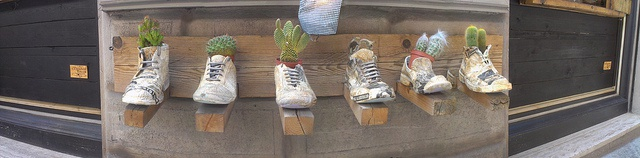Describe the objects in this image and their specific colors. I can see vase in gray, darkgray, and lightgray tones, vase in gray, darkgray, lightgray, brown, and tan tones, potted plant in gray and olive tones, potted plant in gray, darkgray, brown, lightgray, and lightblue tones, and potted plant in gray, olive, and tan tones in this image. 